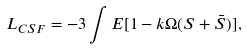Convert formula to latex. <formula><loc_0><loc_0><loc_500><loc_500>L _ { C S F } = - 3 \int E [ 1 - k \Omega ( S + \bar { S } ) ] ,</formula> 